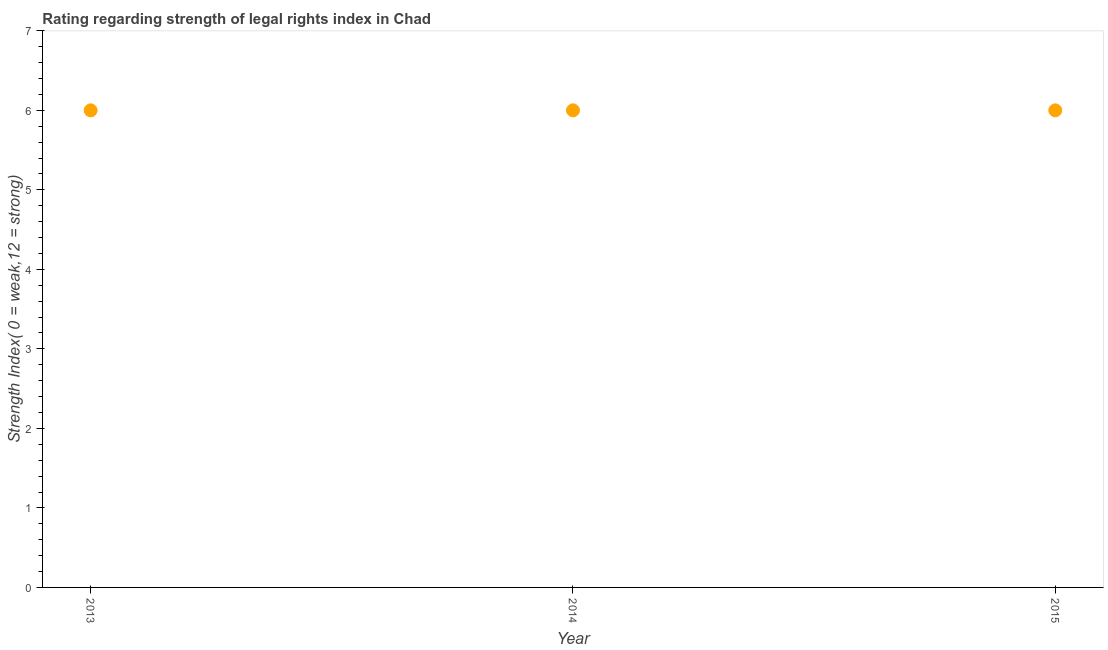In which year was the strength of legal rights index minimum?
Provide a succinct answer. 2013. What is the sum of the strength of legal rights index?
Make the answer very short. 18. What is the difference between the strength of legal rights index in 2013 and 2014?
Your answer should be compact. 0. Do a majority of the years between 2015 and 2014 (inclusive) have strength of legal rights index greater than 0.4 ?
Provide a succinct answer. No. What is the ratio of the strength of legal rights index in 2014 to that in 2015?
Offer a very short reply. 1. What is the difference between the highest and the lowest strength of legal rights index?
Provide a short and direct response. 0. In how many years, is the strength of legal rights index greater than the average strength of legal rights index taken over all years?
Ensure brevity in your answer.  0. How many dotlines are there?
Provide a succinct answer. 1. Are the values on the major ticks of Y-axis written in scientific E-notation?
Make the answer very short. No. What is the title of the graph?
Offer a very short reply. Rating regarding strength of legal rights index in Chad. What is the label or title of the Y-axis?
Provide a succinct answer. Strength Index( 0 = weak,12 = strong). What is the Strength Index( 0 = weak,12 = strong) in 2013?
Make the answer very short. 6. What is the Strength Index( 0 = weak,12 = strong) in 2015?
Offer a very short reply. 6. What is the difference between the Strength Index( 0 = weak,12 = strong) in 2013 and 2015?
Offer a very short reply. 0. What is the difference between the Strength Index( 0 = weak,12 = strong) in 2014 and 2015?
Make the answer very short. 0. What is the ratio of the Strength Index( 0 = weak,12 = strong) in 2013 to that in 2014?
Your answer should be compact. 1. What is the ratio of the Strength Index( 0 = weak,12 = strong) in 2013 to that in 2015?
Provide a short and direct response. 1. What is the ratio of the Strength Index( 0 = weak,12 = strong) in 2014 to that in 2015?
Give a very brief answer. 1. 